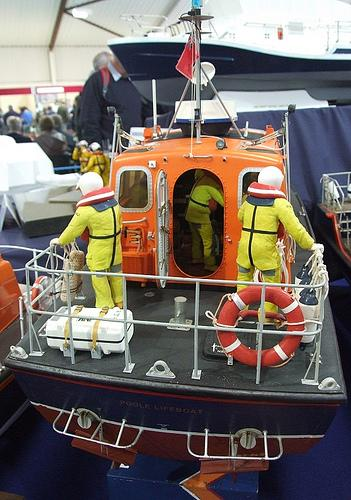Who are the men wearing yellow?

Choices:
A) crew
B) doctors
C) chefs
D) students crew 